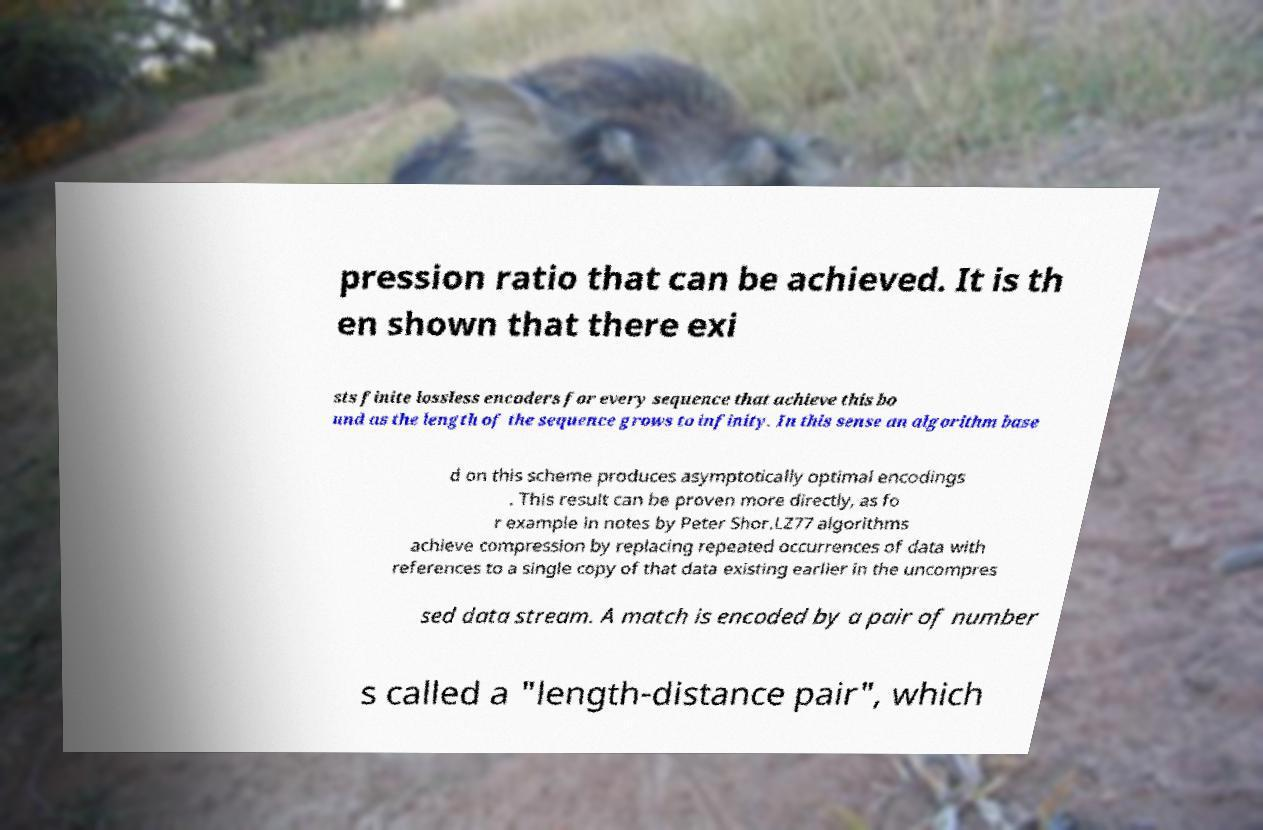For documentation purposes, I need the text within this image transcribed. Could you provide that? pression ratio that can be achieved. It is th en shown that there exi sts finite lossless encoders for every sequence that achieve this bo und as the length of the sequence grows to infinity. In this sense an algorithm base d on this scheme produces asymptotically optimal encodings . This result can be proven more directly, as fo r example in notes by Peter Shor.LZ77 algorithms achieve compression by replacing repeated occurrences of data with references to a single copy of that data existing earlier in the uncompres sed data stream. A match is encoded by a pair of number s called a "length-distance pair", which 